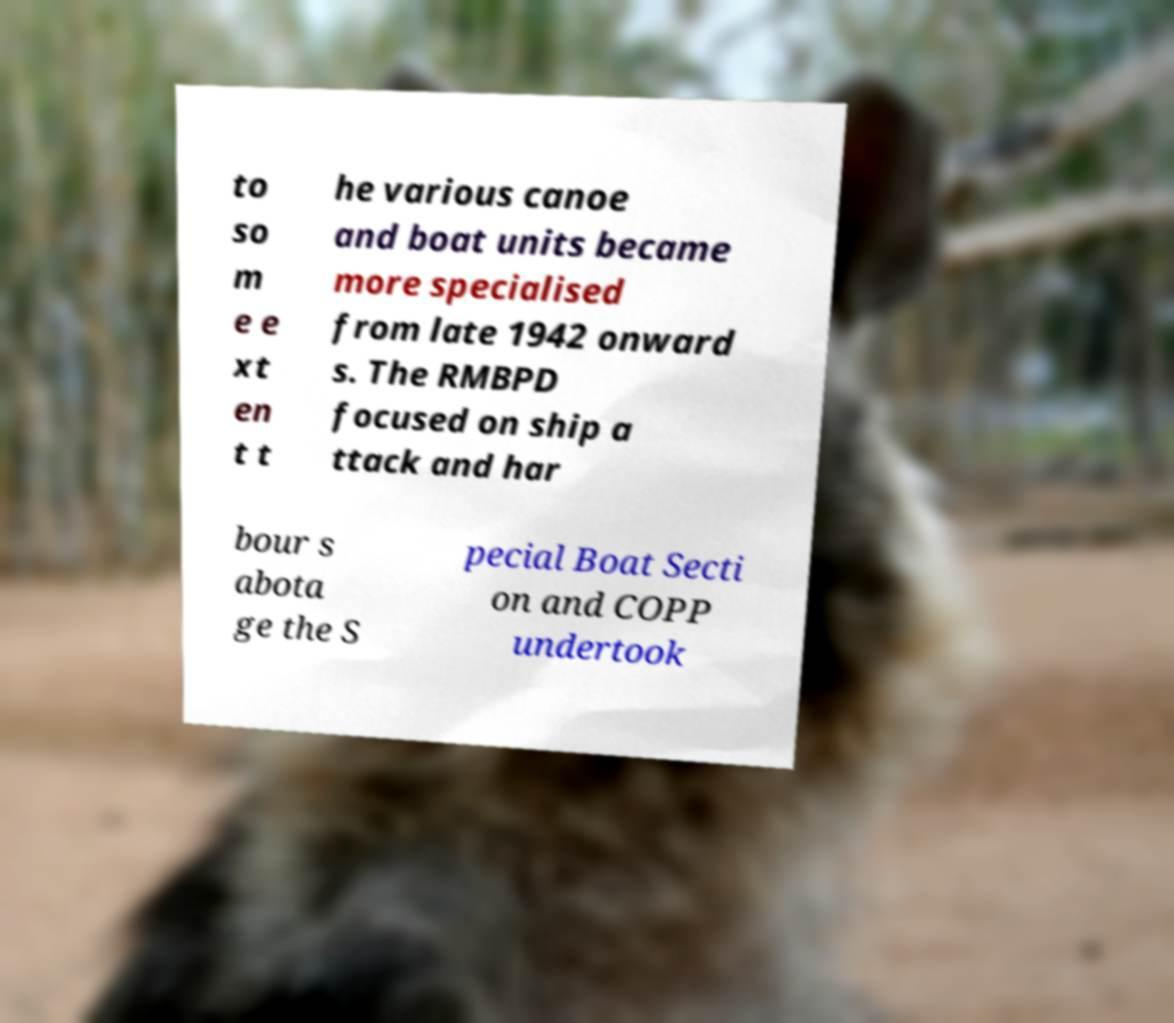Could you assist in decoding the text presented in this image and type it out clearly? to so m e e xt en t t he various canoe and boat units became more specialised from late 1942 onward s. The RMBPD focused on ship a ttack and har bour s abota ge the S pecial Boat Secti on and COPP undertook 